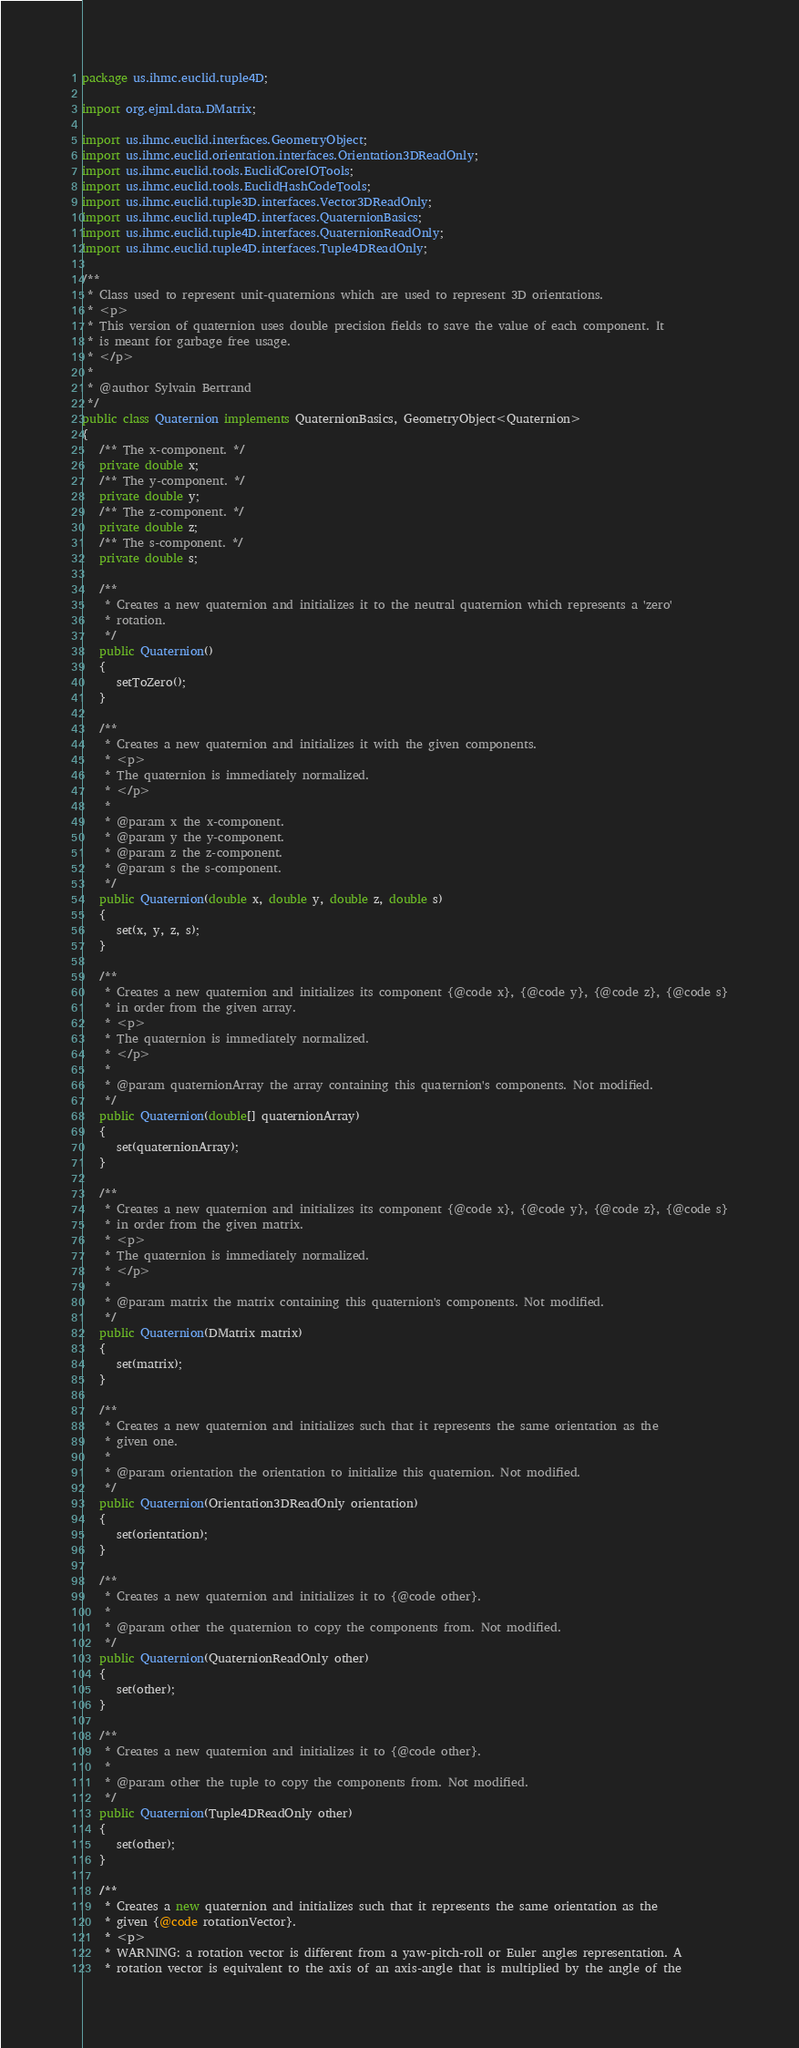<code> <loc_0><loc_0><loc_500><loc_500><_Java_>package us.ihmc.euclid.tuple4D;

import org.ejml.data.DMatrix;

import us.ihmc.euclid.interfaces.GeometryObject;
import us.ihmc.euclid.orientation.interfaces.Orientation3DReadOnly;
import us.ihmc.euclid.tools.EuclidCoreIOTools;
import us.ihmc.euclid.tools.EuclidHashCodeTools;
import us.ihmc.euclid.tuple3D.interfaces.Vector3DReadOnly;
import us.ihmc.euclid.tuple4D.interfaces.QuaternionBasics;
import us.ihmc.euclid.tuple4D.interfaces.QuaternionReadOnly;
import us.ihmc.euclid.tuple4D.interfaces.Tuple4DReadOnly;

/**
 * Class used to represent unit-quaternions which are used to represent 3D orientations.
 * <p>
 * This version of quaternion uses double precision fields to save the value of each component. It
 * is meant for garbage free usage.
 * </p>
 *
 * @author Sylvain Bertrand
 */
public class Quaternion implements QuaternionBasics, GeometryObject<Quaternion>
{
   /** The x-component. */
   private double x;
   /** The y-component. */
   private double y;
   /** The z-component. */
   private double z;
   /** The s-component. */
   private double s;

   /**
    * Creates a new quaternion and initializes it to the neutral quaternion which represents a 'zero'
    * rotation.
    */
   public Quaternion()
   {
      setToZero();
   }

   /**
    * Creates a new quaternion and initializes it with the given components.
    * <p>
    * The quaternion is immediately normalized.
    * </p>
    *
    * @param x the x-component.
    * @param y the y-component.
    * @param z the z-component.
    * @param s the s-component.
    */
   public Quaternion(double x, double y, double z, double s)
   {
      set(x, y, z, s);
   }

   /**
    * Creates a new quaternion and initializes its component {@code x}, {@code y}, {@code z}, {@code s}
    * in order from the given array.
    * <p>
    * The quaternion is immediately normalized.
    * </p>
    *
    * @param quaternionArray the array containing this quaternion's components. Not modified.
    */
   public Quaternion(double[] quaternionArray)
   {
      set(quaternionArray);
   }

   /**
    * Creates a new quaternion and initializes its component {@code x}, {@code y}, {@code z}, {@code s}
    * in order from the given matrix.
    * <p>
    * The quaternion is immediately normalized.
    * </p>
    *
    * @param matrix the matrix containing this quaternion's components. Not modified.
    */
   public Quaternion(DMatrix matrix)
   {
      set(matrix);
   }

   /**
    * Creates a new quaternion and initializes such that it represents the same orientation as the
    * given one.
    *
    * @param orientation the orientation to initialize this quaternion. Not modified.
    */
   public Quaternion(Orientation3DReadOnly orientation)
   {
      set(orientation);
   }

   /**
    * Creates a new quaternion and initializes it to {@code other}.
    *
    * @param other the quaternion to copy the components from. Not modified.
    */
   public Quaternion(QuaternionReadOnly other)
   {
      set(other);
   }

   /**
    * Creates a new quaternion and initializes it to {@code other}.
    *
    * @param other the tuple to copy the components from. Not modified.
    */
   public Quaternion(Tuple4DReadOnly other)
   {
      set(other);
   }

   /**
    * Creates a new quaternion and initializes such that it represents the same orientation as the
    * given {@code rotationVector}.
    * <p>
    * WARNING: a rotation vector is different from a yaw-pitch-roll or Euler angles representation. A
    * rotation vector is equivalent to the axis of an axis-angle that is multiplied by the angle of the</code> 